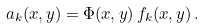<formula> <loc_0><loc_0><loc_500><loc_500>a _ { k } ( x , y ) = \Phi ( x , y ) \, f _ { k } ( x , y ) \, .</formula> 